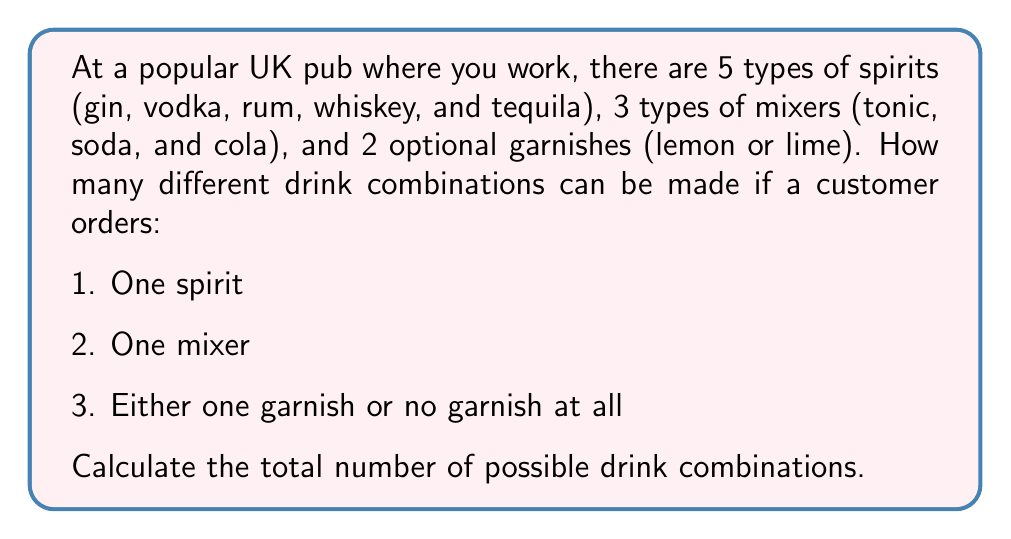Solve this math problem. Let's break this down step-by-step using the multiplication principle of counting:

1. Choosing a spirit:
   There are 5 choices for the spirit.

2. Choosing a mixer:
   There are 3 choices for the mixer.

3. Choosing a garnish:
   There are 3 possibilities for the garnish:
   - Lemon
   - Lime
   - No garnish

Now, we can apply the multiplication principle. The total number of combinations is:

$$ \text{Total combinations} = \text{Spirit choices} \times \text{Mixer choices} \times \text{Garnish choices} $$

$$ \text{Total combinations} = 5 \times 3 \times 3 = 45 $$

We can also express this using permutation notation:

$$ P(5,1) \times P(3,1) \times P(3,1) = 5 \times 3 \times 3 = 45 $$

Where $P(n,r)$ represents the number of permutations of $n$ items taken $r$ at a time.
Answer: $$45 \text{ possible drink combinations}$$ 